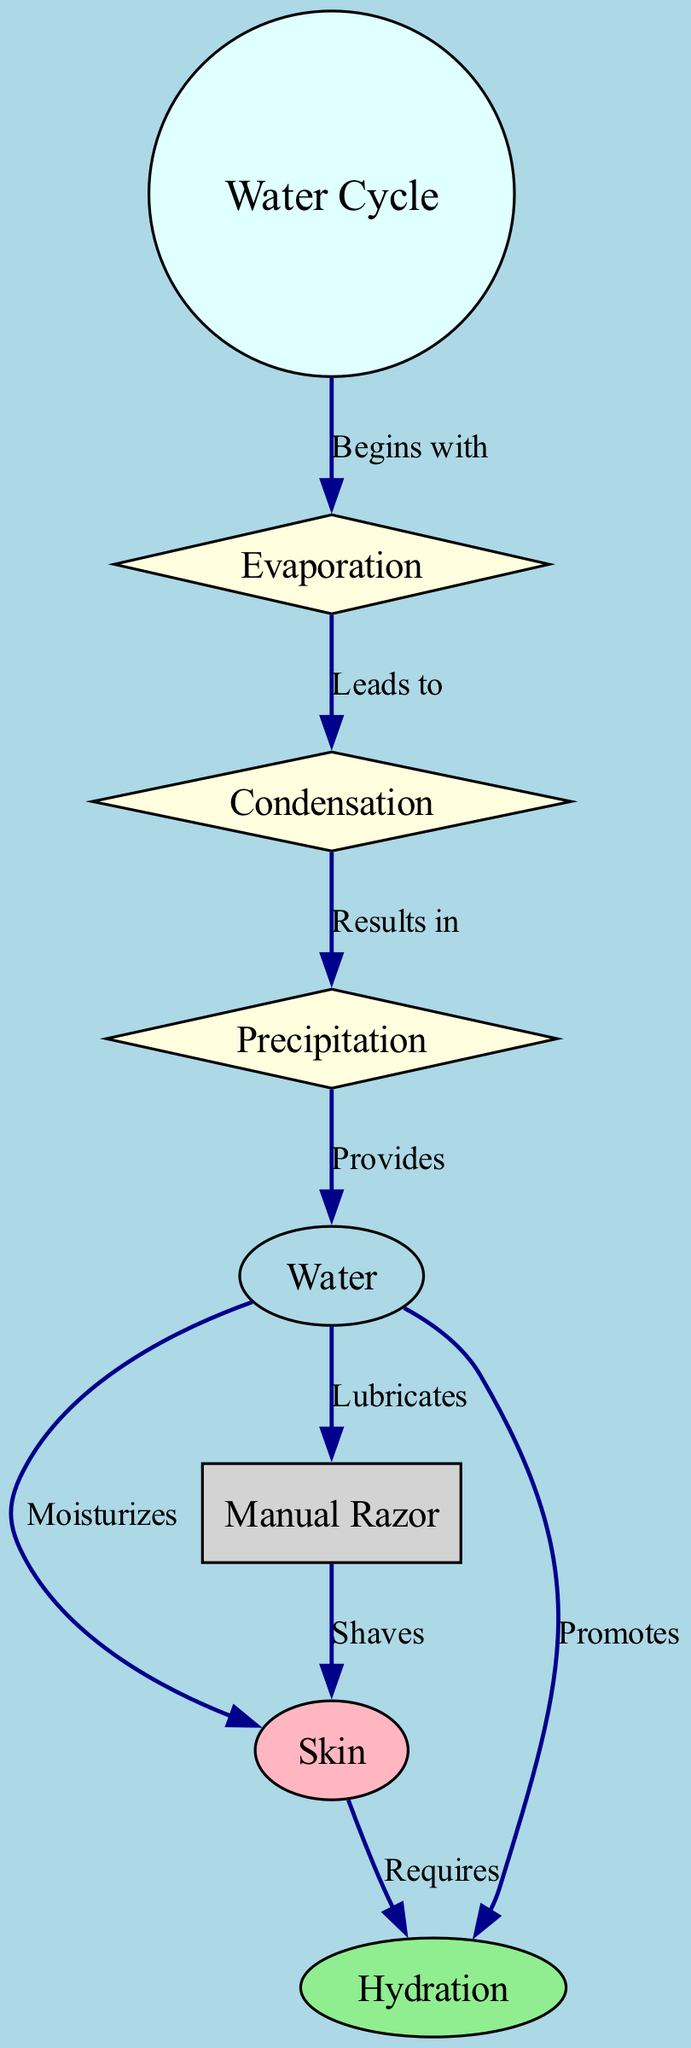What are the main processes in the water cycle? The nodes labeled "Evaporation," "Condensation," and "Precipitation" represent the main processes of the water cycle shown in the diagram.
Answer: Evaporation, Condensation, Precipitation How does water affect skin during shaving? The edge connecting "Water" to "Skin" labeled "Moisturizes" shows that water moisturizes the skin, which is vital during the shaving process.
Answer: Moisturizes What role does water play in hydration? The "Water" node is connected to "Hydration" with the label "Promotes," indicating that water promotes hydration in the skin.
Answer: Promotes Which tool is directly associated with skin shaving? The "Manual Razor" node is connected to the "Skin" node with the label "Shaves," indicating that the manual razor is used for shaving skin.
Answer: Manual Razor How many edges are there in the diagram? The edges between the nodes represent relationships and there are a total of 9 edges shown between the nodes in the diagram.
Answer: 9 What does skin require for hydration? The "Skin" node is connected to "Hydration" with the label "Requires," indicating that skin needs something to stay hydrated.
Answer: Requires What process begins the water cycle? The diagram shows that "Evaporation" begins from the "Water Cycle" node with the label "Begins with."
Answer: Evaporation What is the relationship between water and manual razors? The "Manual Razor" node is connected to the "Water" node with the label "Lubricates," indicating that water lubricates the manual razor during use.
Answer: Lubricates Which process leads to precipitation? The "Condensation" node is shown to lead to the "Precipitation" node in the diagram, indicating that condensation results in precipitation.
Answer: Condensation 